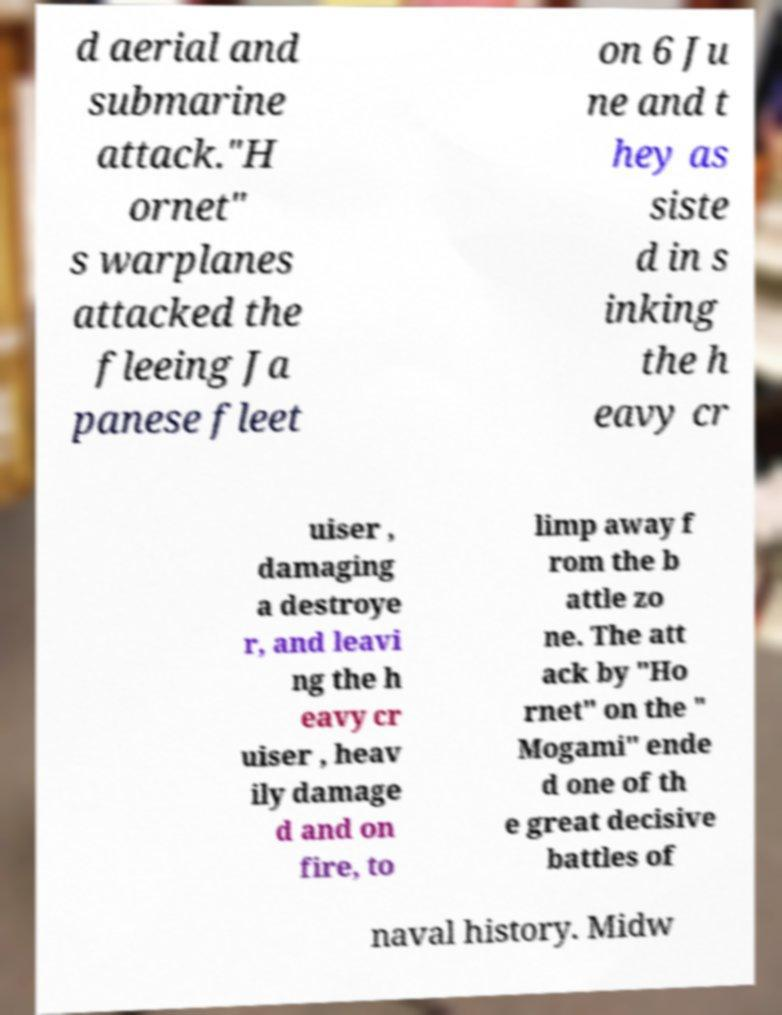Can you read and provide the text displayed in the image?This photo seems to have some interesting text. Can you extract and type it out for me? d aerial and submarine attack."H ornet" s warplanes attacked the fleeing Ja panese fleet on 6 Ju ne and t hey as siste d in s inking the h eavy cr uiser , damaging a destroye r, and leavi ng the h eavy cr uiser , heav ily damage d and on fire, to limp away f rom the b attle zo ne. The att ack by "Ho rnet" on the " Mogami" ende d one of th e great decisive battles of naval history. Midw 